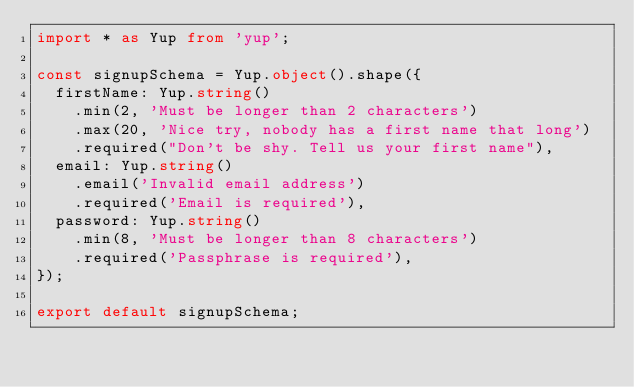Convert code to text. <code><loc_0><loc_0><loc_500><loc_500><_TypeScript_>import * as Yup from 'yup';

const signupSchema = Yup.object().shape({
  firstName: Yup.string()
    .min(2, 'Must be longer than 2 characters')
    .max(20, 'Nice try, nobody has a first name that long')
    .required("Don't be shy. Tell us your first name"),
  email: Yup.string()
    .email('Invalid email address')
    .required('Email is required'),
  password: Yup.string()
    .min(8, 'Must be longer than 8 characters')
    .required('Passphrase is required'),
});

export default signupSchema;
</code> 